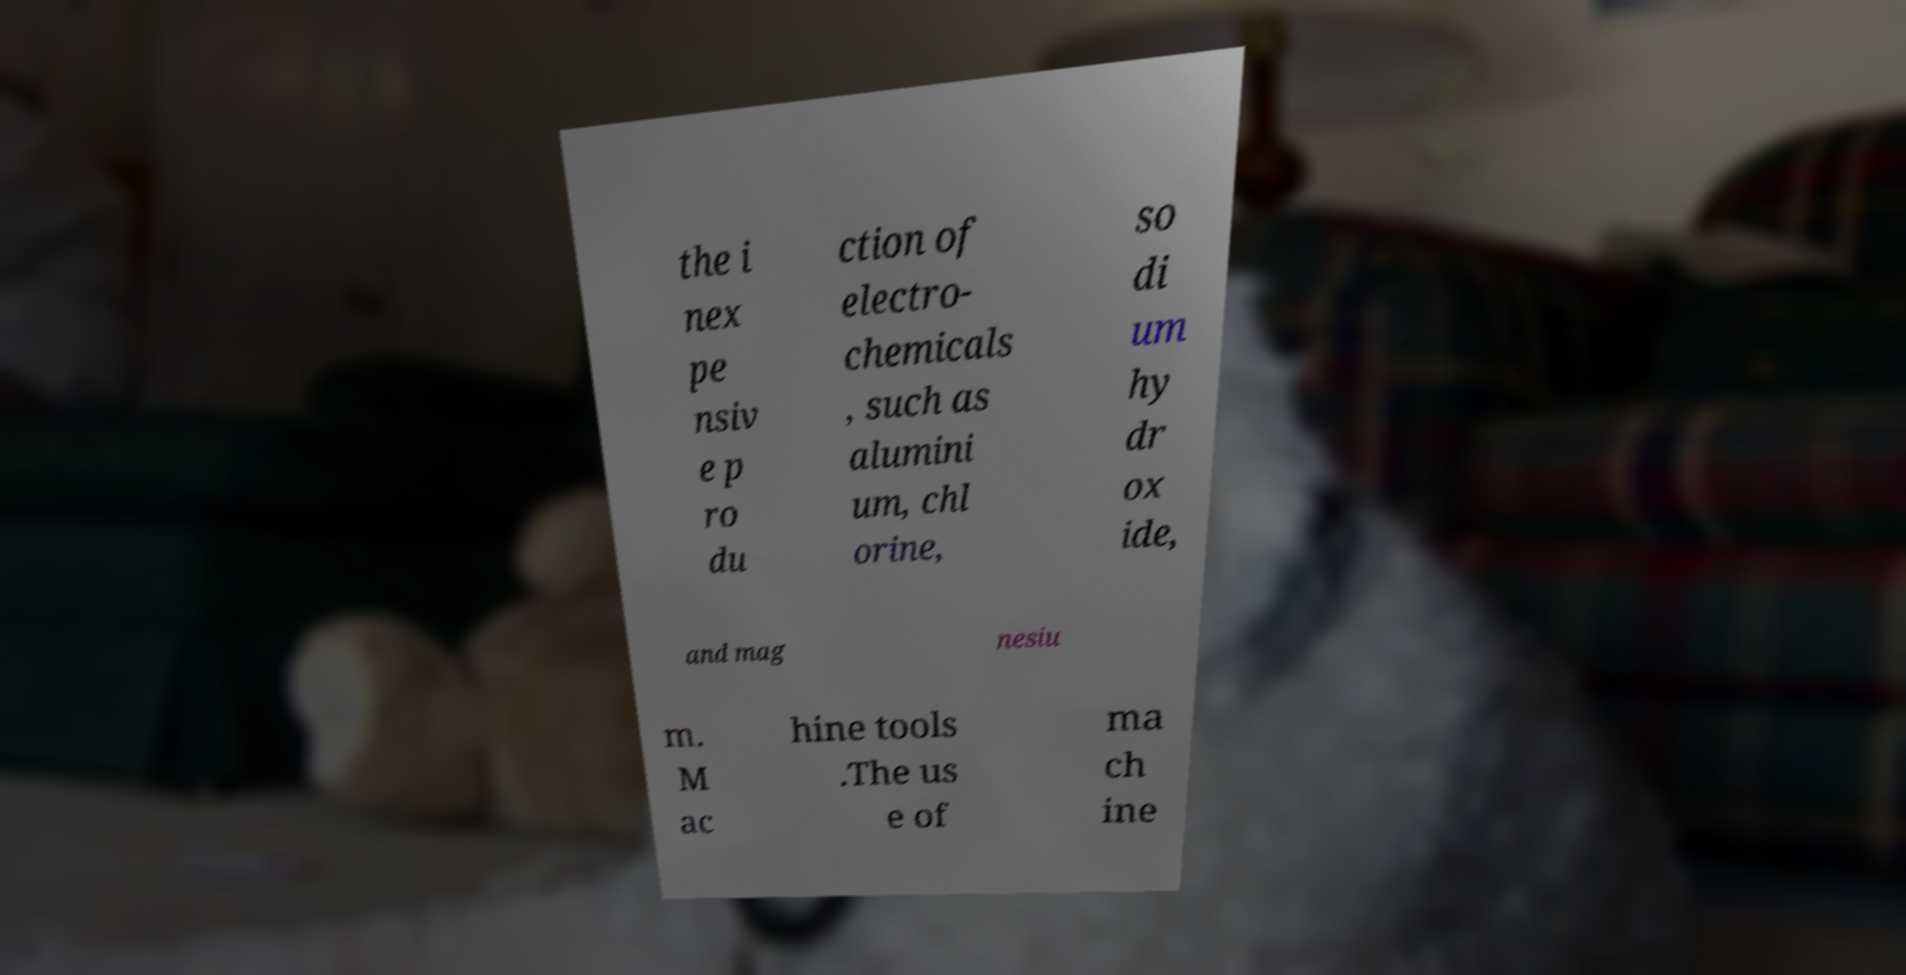I need the written content from this picture converted into text. Can you do that? the i nex pe nsiv e p ro du ction of electro- chemicals , such as alumini um, chl orine, so di um hy dr ox ide, and mag nesiu m. M ac hine tools .The us e of ma ch ine 